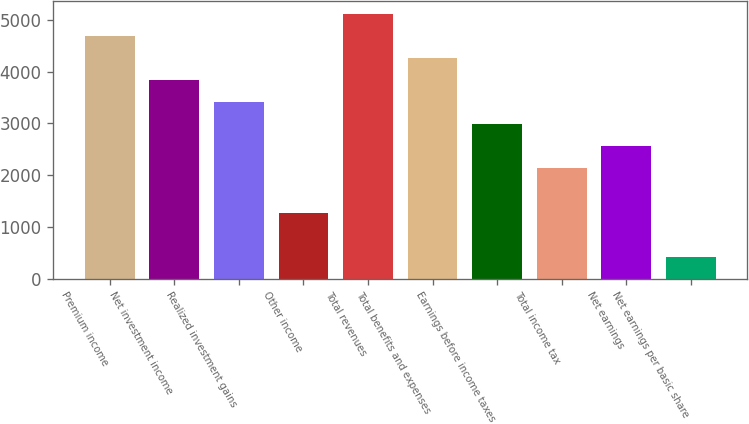Convert chart. <chart><loc_0><loc_0><loc_500><loc_500><bar_chart><fcel>Premium income<fcel>Net investment income<fcel>Realized investment gains<fcel>Other income<fcel>Total revenues<fcel>Total benefits and expenses<fcel>Earnings before income taxes<fcel>Total income tax<fcel>Net earnings<fcel>Net earnings per basic share<nl><fcel>4686.02<fcel>3834.06<fcel>3408.08<fcel>1278.18<fcel>5112<fcel>4260.04<fcel>2982.1<fcel>2130.14<fcel>2556.12<fcel>426.22<nl></chart> 